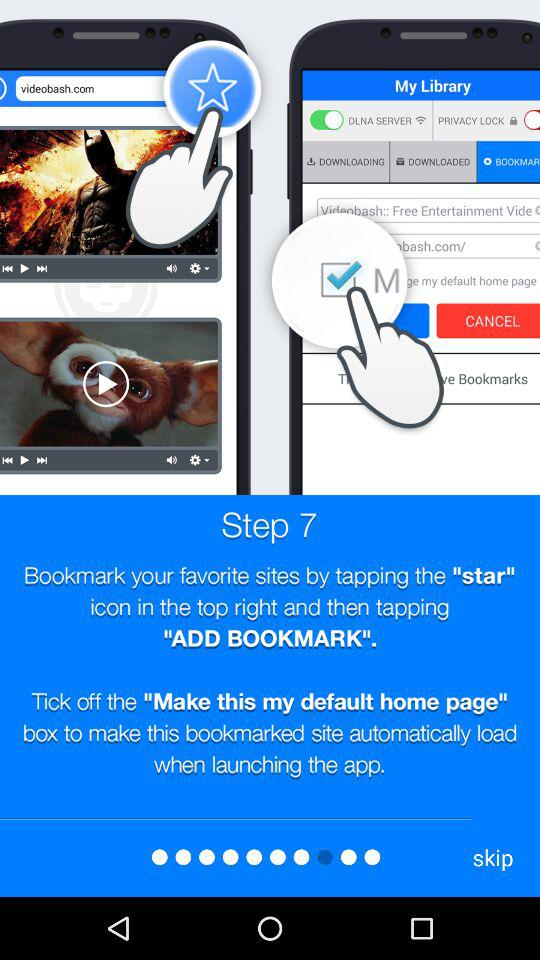How many steps are there in the instructions?
Answer the question using a single word or phrase. 7 